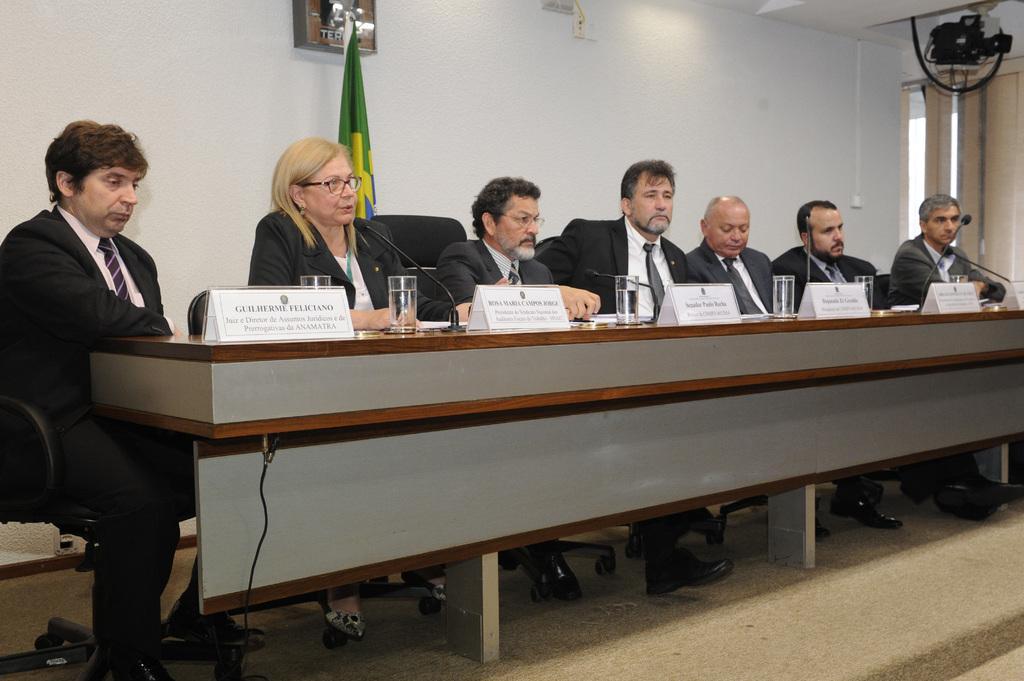Describe this image in one or two sentences. In this image there are six people sitting. On the left side there is one man sitting beside that man one woman is sitting and speaking beside that woman one man is sitting beside that man four men are sitting. In front of them there is one table and six glasses and some name plates on it. On the top of the image there is one flag on the right side of the top corner there is one camera and in the middle of the image there are some switch boards. 